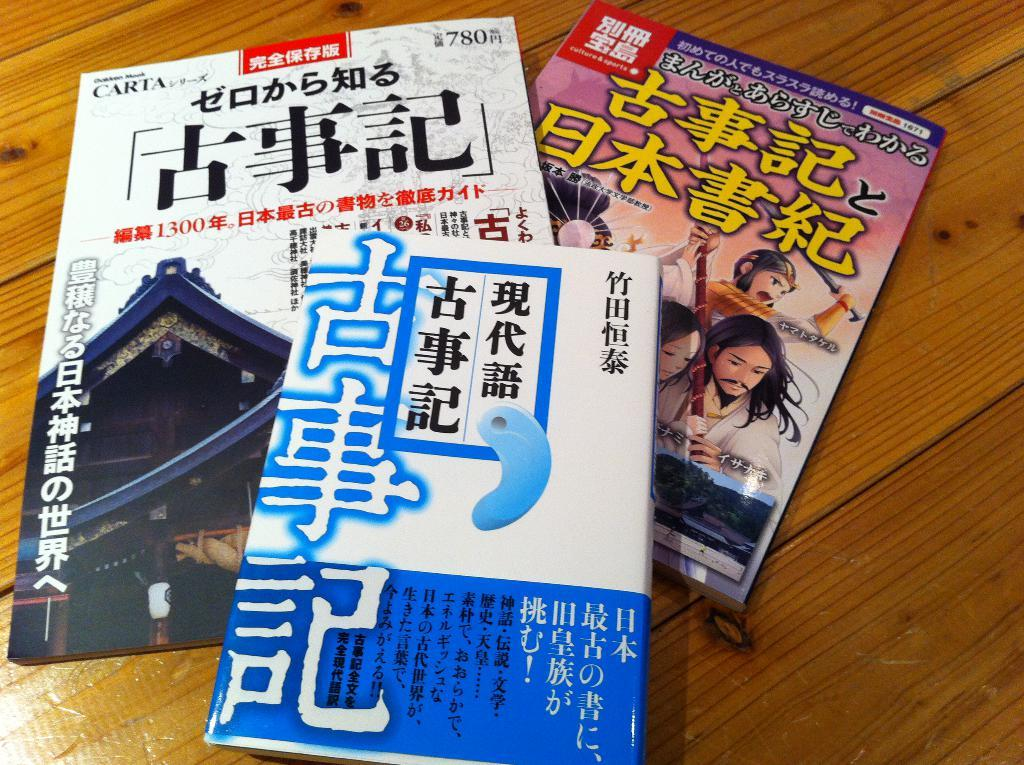How many books are on the table in the image? There are three books on the table in the image. What can be observed about the colors of the books? The books are in multiple colors. What is the color of the table in the image? The table is brown in color. What type of destruction can be seen happening to the books in the image? There is no destruction happening to the books in the image; they are simply sitting on the table. Can you describe the mitten that is being used to read one of the books in the image? There is no mitten present in the image, and the books are not being read. 